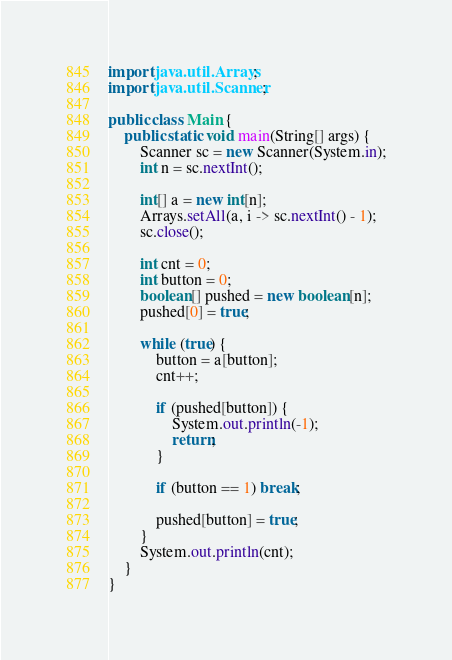<code> <loc_0><loc_0><loc_500><loc_500><_Java_>import java.util.Arrays;
import java.util.Scanner;

public class Main {
	public static void main(String[] args) {
		Scanner sc = new Scanner(System.in);
		int n = sc.nextInt();
		
		int[] a = new int[n];
		Arrays.setAll(a, i -> sc.nextInt() - 1);
		sc.close();
		
		int cnt = 0;
		int button = 0;
		boolean[] pushed = new boolean[n];
		pushed[0] = true;
		
		while (true) {
			button = a[button];
			cnt++;
			
			if (pushed[button]) {
				System.out.println(-1);
				return;
			}
			
			if (button == 1) break;
			
			pushed[button] = true;
		}
		System.out.println(cnt);
	}
}


</code> 